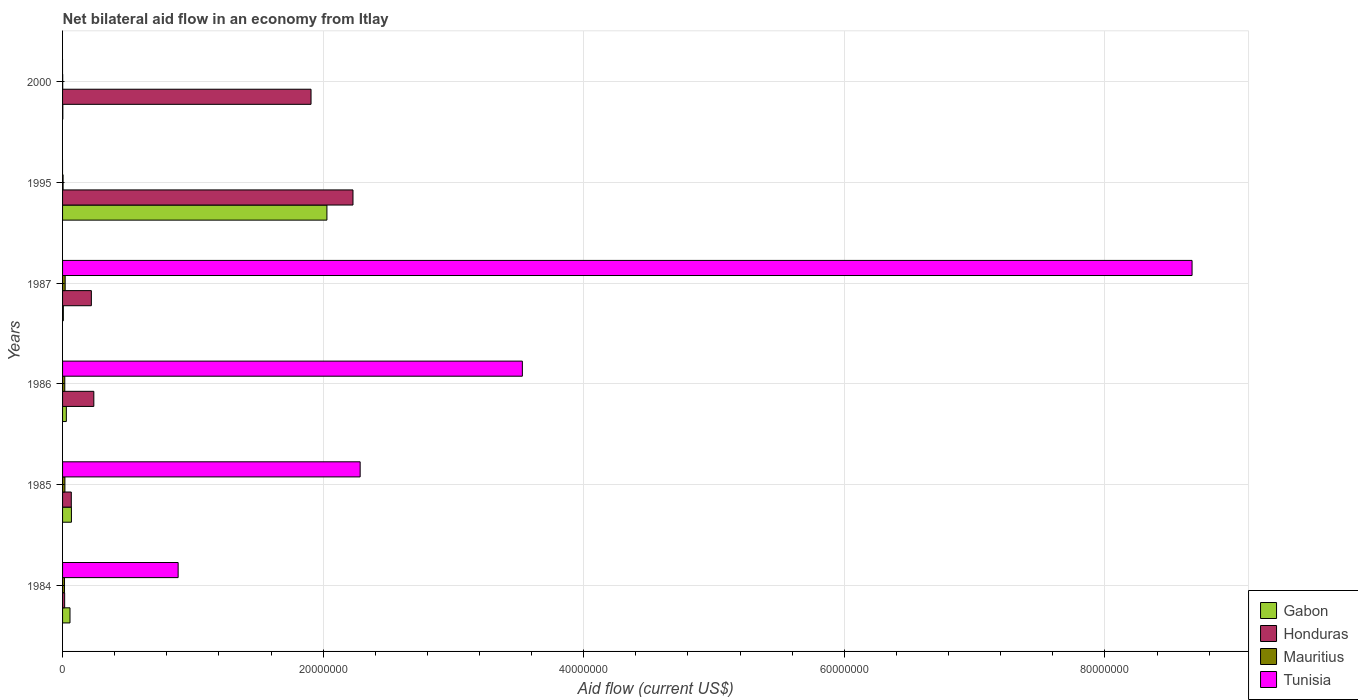How many different coloured bars are there?
Provide a short and direct response. 4. How many groups of bars are there?
Ensure brevity in your answer.  6. Are the number of bars per tick equal to the number of legend labels?
Provide a short and direct response. No. How many bars are there on the 6th tick from the bottom?
Your response must be concise. 3. In how many cases, is the number of bars for a given year not equal to the number of legend labels?
Ensure brevity in your answer.  2. What is the net bilateral aid flow in Tunisia in 1985?
Keep it short and to the point. 2.28e+07. Across all years, what is the maximum net bilateral aid flow in Mauritius?
Your answer should be very brief. 2.00e+05. Across all years, what is the minimum net bilateral aid flow in Honduras?
Keep it short and to the point. 1.60e+05. What is the total net bilateral aid flow in Tunisia in the graph?
Offer a very short reply. 1.54e+08. What is the difference between the net bilateral aid flow in Gabon in 1986 and that in 1995?
Provide a succinct answer. -2.00e+07. What is the difference between the net bilateral aid flow in Tunisia in 1987 and the net bilateral aid flow in Mauritius in 2000?
Keep it short and to the point. 8.67e+07. What is the average net bilateral aid flow in Tunisia per year?
Make the answer very short. 2.56e+07. In the year 1986, what is the difference between the net bilateral aid flow in Tunisia and net bilateral aid flow in Honduras?
Keep it short and to the point. 3.29e+07. What is the ratio of the net bilateral aid flow in Gabon in 1984 to that in 2000?
Offer a very short reply. 28.5. Is the net bilateral aid flow in Tunisia in 1984 less than that in 1987?
Your response must be concise. Yes. What is the difference between the highest and the second highest net bilateral aid flow in Tunisia?
Provide a succinct answer. 5.14e+07. What is the difference between the highest and the lowest net bilateral aid flow in Mauritius?
Your answer should be very brief. 1.90e+05. Is it the case that in every year, the sum of the net bilateral aid flow in Mauritius and net bilateral aid flow in Gabon is greater than the sum of net bilateral aid flow in Honduras and net bilateral aid flow in Tunisia?
Your answer should be very brief. No. Is it the case that in every year, the sum of the net bilateral aid flow in Gabon and net bilateral aid flow in Tunisia is greater than the net bilateral aid flow in Honduras?
Your answer should be very brief. No. How many years are there in the graph?
Make the answer very short. 6. Are the values on the major ticks of X-axis written in scientific E-notation?
Provide a short and direct response. No. Does the graph contain grids?
Keep it short and to the point. Yes. Where does the legend appear in the graph?
Your response must be concise. Bottom right. How many legend labels are there?
Offer a very short reply. 4. How are the legend labels stacked?
Make the answer very short. Vertical. What is the title of the graph?
Make the answer very short. Net bilateral aid flow in an economy from Itlay. Does "European Union" appear as one of the legend labels in the graph?
Provide a short and direct response. No. What is the Aid flow (current US$) in Gabon in 1984?
Offer a terse response. 5.70e+05. What is the Aid flow (current US$) in Mauritius in 1984?
Make the answer very short. 1.50e+05. What is the Aid flow (current US$) of Tunisia in 1984?
Offer a terse response. 8.87e+06. What is the Aid flow (current US$) of Gabon in 1985?
Your response must be concise. 6.80e+05. What is the Aid flow (current US$) of Honduras in 1985?
Give a very brief answer. 6.70e+05. What is the Aid flow (current US$) of Tunisia in 1985?
Provide a short and direct response. 2.28e+07. What is the Aid flow (current US$) in Gabon in 1986?
Your answer should be compact. 2.90e+05. What is the Aid flow (current US$) in Honduras in 1986?
Keep it short and to the point. 2.40e+06. What is the Aid flow (current US$) of Tunisia in 1986?
Make the answer very short. 3.53e+07. What is the Aid flow (current US$) of Gabon in 1987?
Your response must be concise. 6.00e+04. What is the Aid flow (current US$) in Honduras in 1987?
Ensure brevity in your answer.  2.21e+06. What is the Aid flow (current US$) of Mauritius in 1987?
Offer a terse response. 2.00e+05. What is the Aid flow (current US$) in Tunisia in 1987?
Offer a terse response. 8.67e+07. What is the Aid flow (current US$) of Gabon in 1995?
Ensure brevity in your answer.  2.03e+07. What is the Aid flow (current US$) in Honduras in 1995?
Make the answer very short. 2.23e+07. What is the Aid flow (current US$) of Mauritius in 1995?
Make the answer very short. 4.00e+04. What is the Aid flow (current US$) in Honduras in 2000?
Offer a terse response. 1.91e+07. Across all years, what is the maximum Aid flow (current US$) of Gabon?
Ensure brevity in your answer.  2.03e+07. Across all years, what is the maximum Aid flow (current US$) in Honduras?
Provide a short and direct response. 2.23e+07. Across all years, what is the maximum Aid flow (current US$) in Mauritius?
Provide a short and direct response. 2.00e+05. Across all years, what is the maximum Aid flow (current US$) in Tunisia?
Provide a succinct answer. 8.67e+07. What is the total Aid flow (current US$) in Gabon in the graph?
Provide a short and direct response. 2.19e+07. What is the total Aid flow (current US$) in Honduras in the graph?
Ensure brevity in your answer.  4.68e+07. What is the total Aid flow (current US$) of Mauritius in the graph?
Make the answer very short. 7.50e+05. What is the total Aid flow (current US$) in Tunisia in the graph?
Make the answer very short. 1.54e+08. What is the difference between the Aid flow (current US$) in Gabon in 1984 and that in 1985?
Make the answer very short. -1.10e+05. What is the difference between the Aid flow (current US$) in Honduras in 1984 and that in 1985?
Ensure brevity in your answer.  -5.10e+05. What is the difference between the Aid flow (current US$) of Tunisia in 1984 and that in 1985?
Your response must be concise. -1.40e+07. What is the difference between the Aid flow (current US$) in Gabon in 1984 and that in 1986?
Your answer should be compact. 2.80e+05. What is the difference between the Aid flow (current US$) of Honduras in 1984 and that in 1986?
Your response must be concise. -2.24e+06. What is the difference between the Aid flow (current US$) in Mauritius in 1984 and that in 1986?
Make the answer very short. -2.00e+04. What is the difference between the Aid flow (current US$) in Tunisia in 1984 and that in 1986?
Provide a succinct answer. -2.64e+07. What is the difference between the Aid flow (current US$) in Gabon in 1984 and that in 1987?
Ensure brevity in your answer.  5.10e+05. What is the difference between the Aid flow (current US$) of Honduras in 1984 and that in 1987?
Your response must be concise. -2.05e+06. What is the difference between the Aid flow (current US$) of Mauritius in 1984 and that in 1987?
Provide a succinct answer. -5.00e+04. What is the difference between the Aid flow (current US$) in Tunisia in 1984 and that in 1987?
Ensure brevity in your answer.  -7.78e+07. What is the difference between the Aid flow (current US$) in Gabon in 1984 and that in 1995?
Make the answer very short. -1.97e+07. What is the difference between the Aid flow (current US$) of Honduras in 1984 and that in 1995?
Your answer should be very brief. -2.21e+07. What is the difference between the Aid flow (current US$) of Mauritius in 1984 and that in 1995?
Give a very brief answer. 1.10e+05. What is the difference between the Aid flow (current US$) in Gabon in 1984 and that in 2000?
Provide a succinct answer. 5.50e+05. What is the difference between the Aid flow (current US$) in Honduras in 1984 and that in 2000?
Provide a short and direct response. -1.89e+07. What is the difference between the Aid flow (current US$) in Gabon in 1985 and that in 1986?
Your answer should be compact. 3.90e+05. What is the difference between the Aid flow (current US$) in Honduras in 1985 and that in 1986?
Give a very brief answer. -1.73e+06. What is the difference between the Aid flow (current US$) of Tunisia in 1985 and that in 1986?
Your answer should be very brief. -1.24e+07. What is the difference between the Aid flow (current US$) of Gabon in 1985 and that in 1987?
Your answer should be very brief. 6.20e+05. What is the difference between the Aid flow (current US$) in Honduras in 1985 and that in 1987?
Provide a succinct answer. -1.54e+06. What is the difference between the Aid flow (current US$) of Mauritius in 1985 and that in 1987?
Keep it short and to the point. -2.00e+04. What is the difference between the Aid flow (current US$) in Tunisia in 1985 and that in 1987?
Your answer should be compact. -6.38e+07. What is the difference between the Aid flow (current US$) in Gabon in 1985 and that in 1995?
Provide a short and direct response. -1.96e+07. What is the difference between the Aid flow (current US$) in Honduras in 1985 and that in 1995?
Your answer should be very brief. -2.16e+07. What is the difference between the Aid flow (current US$) in Mauritius in 1985 and that in 1995?
Ensure brevity in your answer.  1.40e+05. What is the difference between the Aid flow (current US$) of Honduras in 1985 and that in 2000?
Your response must be concise. -1.84e+07. What is the difference between the Aid flow (current US$) in Mauritius in 1985 and that in 2000?
Keep it short and to the point. 1.70e+05. What is the difference between the Aid flow (current US$) of Gabon in 1986 and that in 1987?
Offer a terse response. 2.30e+05. What is the difference between the Aid flow (current US$) in Honduras in 1986 and that in 1987?
Your answer should be compact. 1.90e+05. What is the difference between the Aid flow (current US$) of Tunisia in 1986 and that in 1987?
Offer a terse response. -5.14e+07. What is the difference between the Aid flow (current US$) of Gabon in 1986 and that in 1995?
Offer a terse response. -2.00e+07. What is the difference between the Aid flow (current US$) in Honduras in 1986 and that in 1995?
Your response must be concise. -1.99e+07. What is the difference between the Aid flow (current US$) in Mauritius in 1986 and that in 1995?
Provide a succinct answer. 1.30e+05. What is the difference between the Aid flow (current US$) in Gabon in 1986 and that in 2000?
Your response must be concise. 2.70e+05. What is the difference between the Aid flow (current US$) of Honduras in 1986 and that in 2000?
Keep it short and to the point. -1.67e+07. What is the difference between the Aid flow (current US$) of Gabon in 1987 and that in 1995?
Give a very brief answer. -2.02e+07. What is the difference between the Aid flow (current US$) of Honduras in 1987 and that in 1995?
Ensure brevity in your answer.  -2.01e+07. What is the difference between the Aid flow (current US$) of Gabon in 1987 and that in 2000?
Your response must be concise. 4.00e+04. What is the difference between the Aid flow (current US$) of Honduras in 1987 and that in 2000?
Offer a terse response. -1.69e+07. What is the difference between the Aid flow (current US$) of Mauritius in 1987 and that in 2000?
Ensure brevity in your answer.  1.90e+05. What is the difference between the Aid flow (current US$) of Gabon in 1995 and that in 2000?
Provide a short and direct response. 2.03e+07. What is the difference between the Aid flow (current US$) of Honduras in 1995 and that in 2000?
Keep it short and to the point. 3.22e+06. What is the difference between the Aid flow (current US$) in Mauritius in 1995 and that in 2000?
Your answer should be very brief. 3.00e+04. What is the difference between the Aid flow (current US$) in Gabon in 1984 and the Aid flow (current US$) in Tunisia in 1985?
Ensure brevity in your answer.  -2.23e+07. What is the difference between the Aid flow (current US$) in Honduras in 1984 and the Aid flow (current US$) in Mauritius in 1985?
Offer a very short reply. -2.00e+04. What is the difference between the Aid flow (current US$) in Honduras in 1984 and the Aid flow (current US$) in Tunisia in 1985?
Offer a terse response. -2.27e+07. What is the difference between the Aid flow (current US$) in Mauritius in 1984 and the Aid flow (current US$) in Tunisia in 1985?
Offer a terse response. -2.27e+07. What is the difference between the Aid flow (current US$) of Gabon in 1984 and the Aid flow (current US$) of Honduras in 1986?
Your answer should be compact. -1.83e+06. What is the difference between the Aid flow (current US$) in Gabon in 1984 and the Aid flow (current US$) in Mauritius in 1986?
Offer a very short reply. 4.00e+05. What is the difference between the Aid flow (current US$) in Gabon in 1984 and the Aid flow (current US$) in Tunisia in 1986?
Provide a succinct answer. -3.47e+07. What is the difference between the Aid flow (current US$) in Honduras in 1984 and the Aid flow (current US$) in Mauritius in 1986?
Make the answer very short. -10000. What is the difference between the Aid flow (current US$) of Honduras in 1984 and the Aid flow (current US$) of Tunisia in 1986?
Ensure brevity in your answer.  -3.51e+07. What is the difference between the Aid flow (current US$) in Mauritius in 1984 and the Aid flow (current US$) in Tunisia in 1986?
Your answer should be very brief. -3.51e+07. What is the difference between the Aid flow (current US$) in Gabon in 1984 and the Aid flow (current US$) in Honduras in 1987?
Your answer should be compact. -1.64e+06. What is the difference between the Aid flow (current US$) in Gabon in 1984 and the Aid flow (current US$) in Mauritius in 1987?
Provide a succinct answer. 3.70e+05. What is the difference between the Aid flow (current US$) of Gabon in 1984 and the Aid flow (current US$) of Tunisia in 1987?
Your answer should be compact. -8.61e+07. What is the difference between the Aid flow (current US$) of Honduras in 1984 and the Aid flow (current US$) of Mauritius in 1987?
Your response must be concise. -4.00e+04. What is the difference between the Aid flow (current US$) of Honduras in 1984 and the Aid flow (current US$) of Tunisia in 1987?
Ensure brevity in your answer.  -8.65e+07. What is the difference between the Aid flow (current US$) of Mauritius in 1984 and the Aid flow (current US$) of Tunisia in 1987?
Keep it short and to the point. -8.65e+07. What is the difference between the Aid flow (current US$) in Gabon in 1984 and the Aid flow (current US$) in Honduras in 1995?
Provide a short and direct response. -2.17e+07. What is the difference between the Aid flow (current US$) in Gabon in 1984 and the Aid flow (current US$) in Mauritius in 1995?
Keep it short and to the point. 5.30e+05. What is the difference between the Aid flow (current US$) in Gabon in 1984 and the Aid flow (current US$) in Honduras in 2000?
Offer a terse response. -1.85e+07. What is the difference between the Aid flow (current US$) in Gabon in 1984 and the Aid flow (current US$) in Mauritius in 2000?
Offer a very short reply. 5.60e+05. What is the difference between the Aid flow (current US$) in Gabon in 1985 and the Aid flow (current US$) in Honduras in 1986?
Make the answer very short. -1.72e+06. What is the difference between the Aid flow (current US$) in Gabon in 1985 and the Aid flow (current US$) in Mauritius in 1986?
Offer a very short reply. 5.10e+05. What is the difference between the Aid flow (current US$) in Gabon in 1985 and the Aid flow (current US$) in Tunisia in 1986?
Give a very brief answer. -3.46e+07. What is the difference between the Aid flow (current US$) in Honduras in 1985 and the Aid flow (current US$) in Mauritius in 1986?
Your response must be concise. 5.00e+05. What is the difference between the Aid flow (current US$) of Honduras in 1985 and the Aid flow (current US$) of Tunisia in 1986?
Make the answer very short. -3.46e+07. What is the difference between the Aid flow (current US$) in Mauritius in 1985 and the Aid flow (current US$) in Tunisia in 1986?
Offer a very short reply. -3.51e+07. What is the difference between the Aid flow (current US$) of Gabon in 1985 and the Aid flow (current US$) of Honduras in 1987?
Ensure brevity in your answer.  -1.53e+06. What is the difference between the Aid flow (current US$) in Gabon in 1985 and the Aid flow (current US$) in Mauritius in 1987?
Provide a short and direct response. 4.80e+05. What is the difference between the Aid flow (current US$) of Gabon in 1985 and the Aid flow (current US$) of Tunisia in 1987?
Provide a succinct answer. -8.60e+07. What is the difference between the Aid flow (current US$) in Honduras in 1985 and the Aid flow (current US$) in Tunisia in 1987?
Provide a short and direct response. -8.60e+07. What is the difference between the Aid flow (current US$) in Mauritius in 1985 and the Aid flow (current US$) in Tunisia in 1987?
Give a very brief answer. -8.65e+07. What is the difference between the Aid flow (current US$) in Gabon in 1985 and the Aid flow (current US$) in Honduras in 1995?
Your answer should be compact. -2.16e+07. What is the difference between the Aid flow (current US$) in Gabon in 1985 and the Aid flow (current US$) in Mauritius in 1995?
Provide a succinct answer. 6.40e+05. What is the difference between the Aid flow (current US$) of Honduras in 1985 and the Aid flow (current US$) of Mauritius in 1995?
Give a very brief answer. 6.30e+05. What is the difference between the Aid flow (current US$) of Gabon in 1985 and the Aid flow (current US$) of Honduras in 2000?
Offer a very short reply. -1.84e+07. What is the difference between the Aid flow (current US$) of Gabon in 1985 and the Aid flow (current US$) of Mauritius in 2000?
Your answer should be compact. 6.70e+05. What is the difference between the Aid flow (current US$) in Honduras in 1985 and the Aid flow (current US$) in Mauritius in 2000?
Make the answer very short. 6.60e+05. What is the difference between the Aid flow (current US$) in Gabon in 1986 and the Aid flow (current US$) in Honduras in 1987?
Ensure brevity in your answer.  -1.92e+06. What is the difference between the Aid flow (current US$) in Gabon in 1986 and the Aid flow (current US$) in Mauritius in 1987?
Ensure brevity in your answer.  9.00e+04. What is the difference between the Aid flow (current US$) of Gabon in 1986 and the Aid flow (current US$) of Tunisia in 1987?
Ensure brevity in your answer.  -8.64e+07. What is the difference between the Aid flow (current US$) in Honduras in 1986 and the Aid flow (current US$) in Mauritius in 1987?
Ensure brevity in your answer.  2.20e+06. What is the difference between the Aid flow (current US$) of Honduras in 1986 and the Aid flow (current US$) of Tunisia in 1987?
Provide a succinct answer. -8.43e+07. What is the difference between the Aid flow (current US$) of Mauritius in 1986 and the Aid flow (current US$) of Tunisia in 1987?
Your answer should be very brief. -8.65e+07. What is the difference between the Aid flow (current US$) of Gabon in 1986 and the Aid flow (current US$) of Honduras in 1995?
Your answer should be very brief. -2.20e+07. What is the difference between the Aid flow (current US$) in Honduras in 1986 and the Aid flow (current US$) in Mauritius in 1995?
Your answer should be compact. 2.36e+06. What is the difference between the Aid flow (current US$) of Gabon in 1986 and the Aid flow (current US$) of Honduras in 2000?
Keep it short and to the point. -1.88e+07. What is the difference between the Aid flow (current US$) in Gabon in 1986 and the Aid flow (current US$) in Mauritius in 2000?
Your answer should be very brief. 2.80e+05. What is the difference between the Aid flow (current US$) in Honduras in 1986 and the Aid flow (current US$) in Mauritius in 2000?
Offer a terse response. 2.39e+06. What is the difference between the Aid flow (current US$) of Gabon in 1987 and the Aid flow (current US$) of Honduras in 1995?
Give a very brief answer. -2.22e+07. What is the difference between the Aid flow (current US$) of Gabon in 1987 and the Aid flow (current US$) of Mauritius in 1995?
Your answer should be very brief. 2.00e+04. What is the difference between the Aid flow (current US$) of Honduras in 1987 and the Aid flow (current US$) of Mauritius in 1995?
Provide a short and direct response. 2.17e+06. What is the difference between the Aid flow (current US$) in Gabon in 1987 and the Aid flow (current US$) in Honduras in 2000?
Offer a very short reply. -1.90e+07. What is the difference between the Aid flow (current US$) in Gabon in 1987 and the Aid flow (current US$) in Mauritius in 2000?
Keep it short and to the point. 5.00e+04. What is the difference between the Aid flow (current US$) in Honduras in 1987 and the Aid flow (current US$) in Mauritius in 2000?
Keep it short and to the point. 2.20e+06. What is the difference between the Aid flow (current US$) of Gabon in 1995 and the Aid flow (current US$) of Honduras in 2000?
Keep it short and to the point. 1.22e+06. What is the difference between the Aid flow (current US$) of Gabon in 1995 and the Aid flow (current US$) of Mauritius in 2000?
Your answer should be compact. 2.03e+07. What is the difference between the Aid flow (current US$) in Honduras in 1995 and the Aid flow (current US$) in Mauritius in 2000?
Your response must be concise. 2.23e+07. What is the average Aid flow (current US$) in Gabon per year?
Provide a short and direct response. 3.65e+06. What is the average Aid flow (current US$) of Honduras per year?
Keep it short and to the point. 7.80e+06. What is the average Aid flow (current US$) of Mauritius per year?
Give a very brief answer. 1.25e+05. What is the average Aid flow (current US$) in Tunisia per year?
Your answer should be compact. 2.56e+07. In the year 1984, what is the difference between the Aid flow (current US$) of Gabon and Aid flow (current US$) of Honduras?
Provide a succinct answer. 4.10e+05. In the year 1984, what is the difference between the Aid flow (current US$) of Gabon and Aid flow (current US$) of Tunisia?
Your answer should be compact. -8.30e+06. In the year 1984, what is the difference between the Aid flow (current US$) of Honduras and Aid flow (current US$) of Tunisia?
Give a very brief answer. -8.71e+06. In the year 1984, what is the difference between the Aid flow (current US$) in Mauritius and Aid flow (current US$) in Tunisia?
Your response must be concise. -8.72e+06. In the year 1985, what is the difference between the Aid flow (current US$) of Gabon and Aid flow (current US$) of Honduras?
Keep it short and to the point. 10000. In the year 1985, what is the difference between the Aid flow (current US$) in Gabon and Aid flow (current US$) in Tunisia?
Your answer should be very brief. -2.22e+07. In the year 1985, what is the difference between the Aid flow (current US$) of Honduras and Aid flow (current US$) of Tunisia?
Provide a succinct answer. -2.22e+07. In the year 1985, what is the difference between the Aid flow (current US$) of Mauritius and Aid flow (current US$) of Tunisia?
Keep it short and to the point. -2.27e+07. In the year 1986, what is the difference between the Aid flow (current US$) of Gabon and Aid flow (current US$) of Honduras?
Ensure brevity in your answer.  -2.11e+06. In the year 1986, what is the difference between the Aid flow (current US$) of Gabon and Aid flow (current US$) of Tunisia?
Your answer should be very brief. -3.50e+07. In the year 1986, what is the difference between the Aid flow (current US$) in Honduras and Aid flow (current US$) in Mauritius?
Provide a succinct answer. 2.23e+06. In the year 1986, what is the difference between the Aid flow (current US$) of Honduras and Aid flow (current US$) of Tunisia?
Provide a succinct answer. -3.29e+07. In the year 1986, what is the difference between the Aid flow (current US$) in Mauritius and Aid flow (current US$) in Tunisia?
Provide a succinct answer. -3.51e+07. In the year 1987, what is the difference between the Aid flow (current US$) in Gabon and Aid flow (current US$) in Honduras?
Provide a succinct answer. -2.15e+06. In the year 1987, what is the difference between the Aid flow (current US$) of Gabon and Aid flow (current US$) of Tunisia?
Keep it short and to the point. -8.66e+07. In the year 1987, what is the difference between the Aid flow (current US$) of Honduras and Aid flow (current US$) of Mauritius?
Provide a short and direct response. 2.01e+06. In the year 1987, what is the difference between the Aid flow (current US$) of Honduras and Aid flow (current US$) of Tunisia?
Keep it short and to the point. -8.45e+07. In the year 1987, what is the difference between the Aid flow (current US$) in Mauritius and Aid flow (current US$) in Tunisia?
Your answer should be compact. -8.65e+07. In the year 1995, what is the difference between the Aid flow (current US$) in Gabon and Aid flow (current US$) in Honduras?
Make the answer very short. -2.00e+06. In the year 1995, what is the difference between the Aid flow (current US$) of Gabon and Aid flow (current US$) of Mauritius?
Your response must be concise. 2.02e+07. In the year 1995, what is the difference between the Aid flow (current US$) in Honduras and Aid flow (current US$) in Mauritius?
Your answer should be compact. 2.22e+07. In the year 2000, what is the difference between the Aid flow (current US$) of Gabon and Aid flow (current US$) of Honduras?
Your answer should be compact. -1.90e+07. In the year 2000, what is the difference between the Aid flow (current US$) in Gabon and Aid flow (current US$) in Mauritius?
Ensure brevity in your answer.  10000. In the year 2000, what is the difference between the Aid flow (current US$) in Honduras and Aid flow (current US$) in Mauritius?
Keep it short and to the point. 1.91e+07. What is the ratio of the Aid flow (current US$) in Gabon in 1984 to that in 1985?
Make the answer very short. 0.84. What is the ratio of the Aid flow (current US$) of Honduras in 1984 to that in 1985?
Give a very brief answer. 0.24. What is the ratio of the Aid flow (current US$) of Tunisia in 1984 to that in 1985?
Offer a terse response. 0.39. What is the ratio of the Aid flow (current US$) of Gabon in 1984 to that in 1986?
Ensure brevity in your answer.  1.97. What is the ratio of the Aid flow (current US$) of Honduras in 1984 to that in 1986?
Provide a short and direct response. 0.07. What is the ratio of the Aid flow (current US$) of Mauritius in 1984 to that in 1986?
Your answer should be compact. 0.88. What is the ratio of the Aid flow (current US$) of Tunisia in 1984 to that in 1986?
Your response must be concise. 0.25. What is the ratio of the Aid flow (current US$) of Honduras in 1984 to that in 1987?
Ensure brevity in your answer.  0.07. What is the ratio of the Aid flow (current US$) of Tunisia in 1984 to that in 1987?
Provide a succinct answer. 0.1. What is the ratio of the Aid flow (current US$) in Gabon in 1984 to that in 1995?
Ensure brevity in your answer.  0.03. What is the ratio of the Aid flow (current US$) in Honduras in 1984 to that in 1995?
Make the answer very short. 0.01. What is the ratio of the Aid flow (current US$) of Mauritius in 1984 to that in 1995?
Provide a succinct answer. 3.75. What is the ratio of the Aid flow (current US$) in Gabon in 1984 to that in 2000?
Offer a very short reply. 28.5. What is the ratio of the Aid flow (current US$) of Honduras in 1984 to that in 2000?
Offer a terse response. 0.01. What is the ratio of the Aid flow (current US$) of Mauritius in 1984 to that in 2000?
Your response must be concise. 15. What is the ratio of the Aid flow (current US$) in Gabon in 1985 to that in 1986?
Offer a very short reply. 2.34. What is the ratio of the Aid flow (current US$) in Honduras in 1985 to that in 1986?
Provide a short and direct response. 0.28. What is the ratio of the Aid flow (current US$) in Mauritius in 1985 to that in 1986?
Your response must be concise. 1.06. What is the ratio of the Aid flow (current US$) in Tunisia in 1985 to that in 1986?
Your answer should be compact. 0.65. What is the ratio of the Aid flow (current US$) of Gabon in 1985 to that in 1987?
Offer a terse response. 11.33. What is the ratio of the Aid flow (current US$) in Honduras in 1985 to that in 1987?
Provide a short and direct response. 0.3. What is the ratio of the Aid flow (current US$) in Tunisia in 1985 to that in 1987?
Offer a terse response. 0.26. What is the ratio of the Aid flow (current US$) of Gabon in 1985 to that in 1995?
Your answer should be very brief. 0.03. What is the ratio of the Aid flow (current US$) of Honduras in 1985 to that in 1995?
Provide a succinct answer. 0.03. What is the ratio of the Aid flow (current US$) in Mauritius in 1985 to that in 1995?
Offer a terse response. 4.5. What is the ratio of the Aid flow (current US$) of Gabon in 1985 to that in 2000?
Your answer should be very brief. 34. What is the ratio of the Aid flow (current US$) in Honduras in 1985 to that in 2000?
Ensure brevity in your answer.  0.04. What is the ratio of the Aid flow (current US$) in Gabon in 1986 to that in 1987?
Provide a succinct answer. 4.83. What is the ratio of the Aid flow (current US$) of Honduras in 1986 to that in 1987?
Make the answer very short. 1.09. What is the ratio of the Aid flow (current US$) in Mauritius in 1986 to that in 1987?
Offer a terse response. 0.85. What is the ratio of the Aid flow (current US$) of Tunisia in 1986 to that in 1987?
Your answer should be compact. 0.41. What is the ratio of the Aid flow (current US$) in Gabon in 1986 to that in 1995?
Provide a short and direct response. 0.01. What is the ratio of the Aid flow (current US$) of Honduras in 1986 to that in 1995?
Make the answer very short. 0.11. What is the ratio of the Aid flow (current US$) in Mauritius in 1986 to that in 1995?
Offer a terse response. 4.25. What is the ratio of the Aid flow (current US$) of Honduras in 1986 to that in 2000?
Your response must be concise. 0.13. What is the ratio of the Aid flow (current US$) of Gabon in 1987 to that in 1995?
Your answer should be very brief. 0. What is the ratio of the Aid flow (current US$) of Honduras in 1987 to that in 1995?
Give a very brief answer. 0.1. What is the ratio of the Aid flow (current US$) in Mauritius in 1987 to that in 1995?
Your answer should be compact. 5. What is the ratio of the Aid flow (current US$) of Honduras in 1987 to that in 2000?
Your answer should be very brief. 0.12. What is the ratio of the Aid flow (current US$) in Mauritius in 1987 to that in 2000?
Offer a very short reply. 20. What is the ratio of the Aid flow (current US$) of Gabon in 1995 to that in 2000?
Give a very brief answer. 1014.5. What is the ratio of the Aid flow (current US$) of Honduras in 1995 to that in 2000?
Give a very brief answer. 1.17. What is the difference between the highest and the second highest Aid flow (current US$) in Gabon?
Your response must be concise. 1.96e+07. What is the difference between the highest and the second highest Aid flow (current US$) of Honduras?
Your answer should be very brief. 3.22e+06. What is the difference between the highest and the second highest Aid flow (current US$) in Mauritius?
Your response must be concise. 2.00e+04. What is the difference between the highest and the second highest Aid flow (current US$) in Tunisia?
Ensure brevity in your answer.  5.14e+07. What is the difference between the highest and the lowest Aid flow (current US$) of Gabon?
Offer a terse response. 2.03e+07. What is the difference between the highest and the lowest Aid flow (current US$) of Honduras?
Offer a very short reply. 2.21e+07. What is the difference between the highest and the lowest Aid flow (current US$) of Tunisia?
Make the answer very short. 8.67e+07. 